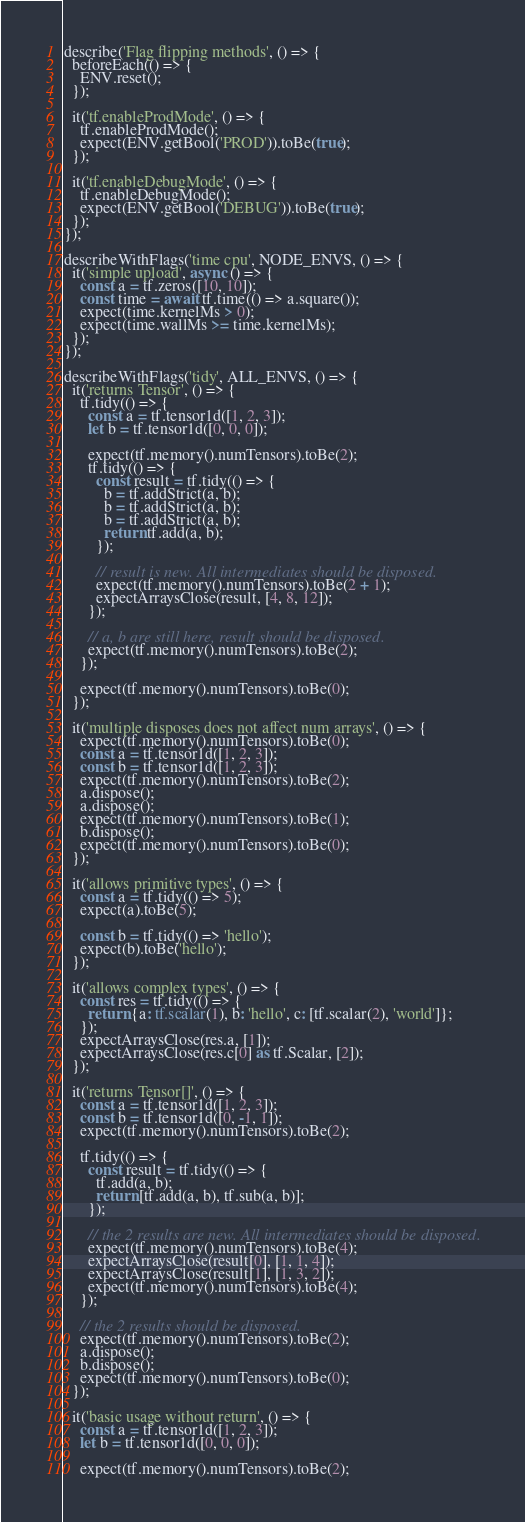Convert code to text. <code><loc_0><loc_0><loc_500><loc_500><_TypeScript_>
describe('Flag flipping methods', () => {
  beforeEach(() => {
    ENV.reset();
  });

  it('tf.enableProdMode', () => {
    tf.enableProdMode();
    expect(ENV.getBool('PROD')).toBe(true);
  });

  it('tf.enableDebugMode', () => {
    tf.enableDebugMode();
    expect(ENV.getBool('DEBUG')).toBe(true);
  });
});

describeWithFlags('time cpu', NODE_ENVS, () => {
  it('simple upload', async () => {
    const a = tf.zeros([10, 10]);
    const time = await tf.time(() => a.square());
    expect(time.kernelMs > 0);
    expect(time.wallMs >= time.kernelMs);
  });
});

describeWithFlags('tidy', ALL_ENVS, () => {
  it('returns Tensor', () => {
    tf.tidy(() => {
      const a = tf.tensor1d([1, 2, 3]);
      let b = tf.tensor1d([0, 0, 0]);

      expect(tf.memory().numTensors).toBe(2);
      tf.tidy(() => {
        const result = tf.tidy(() => {
          b = tf.addStrict(a, b);
          b = tf.addStrict(a, b);
          b = tf.addStrict(a, b);
          return tf.add(a, b);
        });

        // result is new. All intermediates should be disposed.
        expect(tf.memory().numTensors).toBe(2 + 1);
        expectArraysClose(result, [4, 8, 12]);
      });

      // a, b are still here, result should be disposed.
      expect(tf.memory().numTensors).toBe(2);
    });

    expect(tf.memory().numTensors).toBe(0);
  });

  it('multiple disposes does not affect num arrays', () => {
    expect(tf.memory().numTensors).toBe(0);
    const a = tf.tensor1d([1, 2, 3]);
    const b = tf.tensor1d([1, 2, 3]);
    expect(tf.memory().numTensors).toBe(2);
    a.dispose();
    a.dispose();
    expect(tf.memory().numTensors).toBe(1);
    b.dispose();
    expect(tf.memory().numTensors).toBe(0);
  });

  it('allows primitive types', () => {
    const a = tf.tidy(() => 5);
    expect(a).toBe(5);

    const b = tf.tidy(() => 'hello');
    expect(b).toBe('hello');
  });

  it('allows complex types', () => {
    const res = tf.tidy(() => {
      return {a: tf.scalar(1), b: 'hello', c: [tf.scalar(2), 'world']};
    });
    expectArraysClose(res.a, [1]);
    expectArraysClose(res.c[0] as tf.Scalar, [2]);
  });

  it('returns Tensor[]', () => {
    const a = tf.tensor1d([1, 2, 3]);
    const b = tf.tensor1d([0, -1, 1]);
    expect(tf.memory().numTensors).toBe(2);

    tf.tidy(() => {
      const result = tf.tidy(() => {
        tf.add(a, b);
        return [tf.add(a, b), tf.sub(a, b)];
      });

      // the 2 results are new. All intermediates should be disposed.
      expect(tf.memory().numTensors).toBe(4);
      expectArraysClose(result[0], [1, 1, 4]);
      expectArraysClose(result[1], [1, 3, 2]);
      expect(tf.memory().numTensors).toBe(4);
    });

    // the 2 results should be disposed.
    expect(tf.memory().numTensors).toBe(2);
    a.dispose();
    b.dispose();
    expect(tf.memory().numTensors).toBe(0);
  });

  it('basic usage without return', () => {
    const a = tf.tensor1d([1, 2, 3]);
    let b = tf.tensor1d([0, 0, 0]);

    expect(tf.memory().numTensors).toBe(2);
</code> 